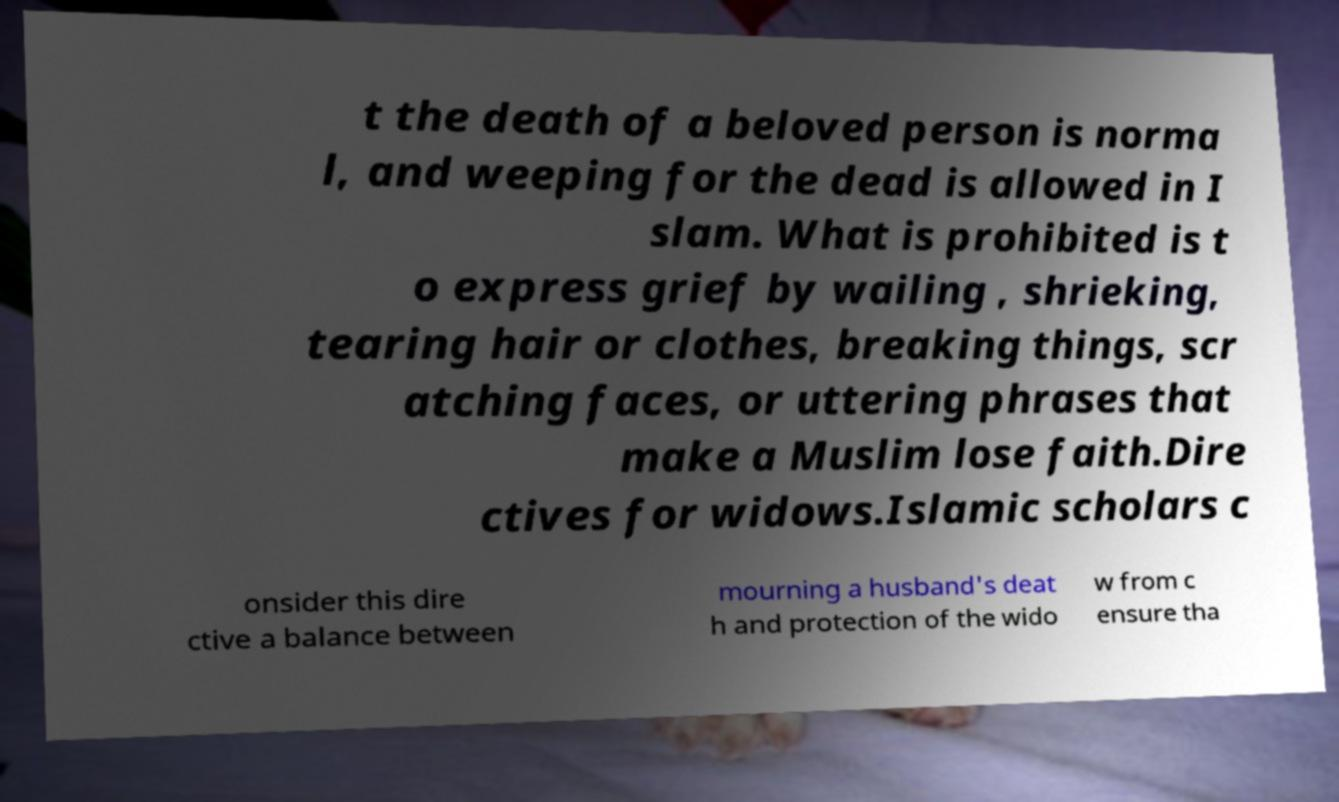For documentation purposes, I need the text within this image transcribed. Could you provide that? t the death of a beloved person is norma l, and weeping for the dead is allowed in I slam. What is prohibited is t o express grief by wailing , shrieking, tearing hair or clothes, breaking things, scr atching faces, or uttering phrases that make a Muslim lose faith.Dire ctives for widows.Islamic scholars c onsider this dire ctive a balance between mourning a husband's deat h and protection of the wido w from c ensure tha 